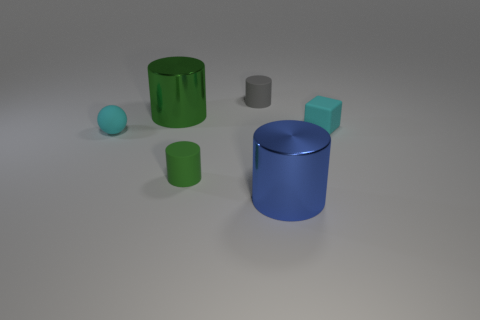Do the green cylinder that is left of the green rubber cylinder and the blue object have the same material? yes 